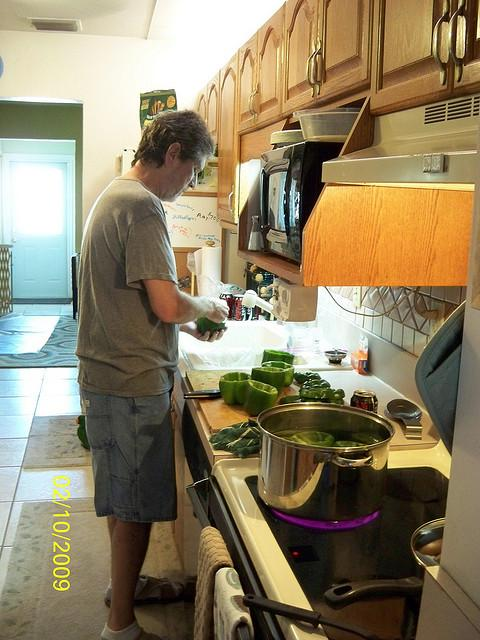What is the person cooking on the stove? peppers 